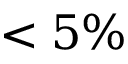Convert formula to latex. <formula><loc_0><loc_0><loc_500><loc_500>< 5 \%</formula> 